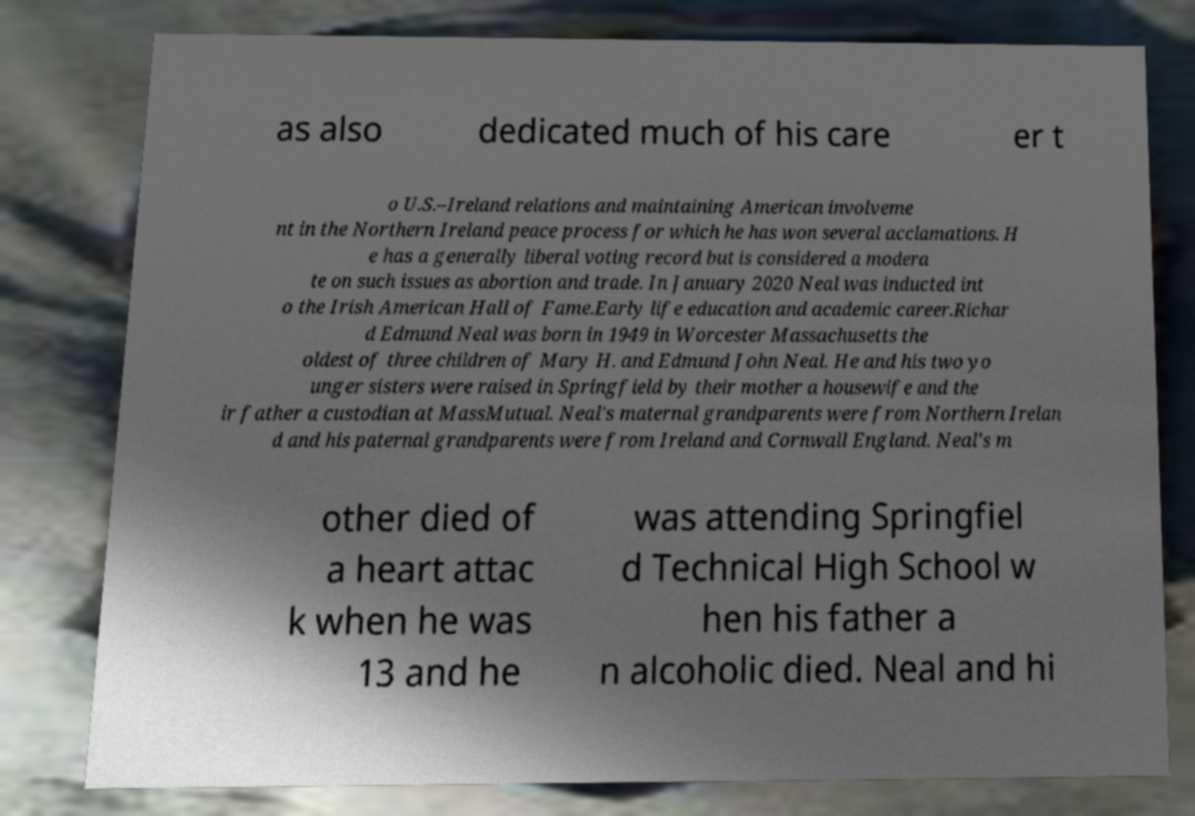Can you accurately transcribe the text from the provided image for me? as also dedicated much of his care er t o U.S.–Ireland relations and maintaining American involveme nt in the Northern Ireland peace process for which he has won several acclamations. H e has a generally liberal voting record but is considered a modera te on such issues as abortion and trade. In January 2020 Neal was inducted int o the Irish American Hall of Fame.Early life education and academic career.Richar d Edmund Neal was born in 1949 in Worcester Massachusetts the oldest of three children of Mary H. and Edmund John Neal. He and his two yo unger sisters were raised in Springfield by their mother a housewife and the ir father a custodian at MassMutual. Neal's maternal grandparents were from Northern Irelan d and his paternal grandparents were from Ireland and Cornwall England. Neal's m other died of a heart attac k when he was 13 and he was attending Springfiel d Technical High School w hen his father a n alcoholic died. Neal and hi 